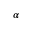Convert formula to latex. <formula><loc_0><loc_0><loc_500><loc_500>\alpha</formula> 